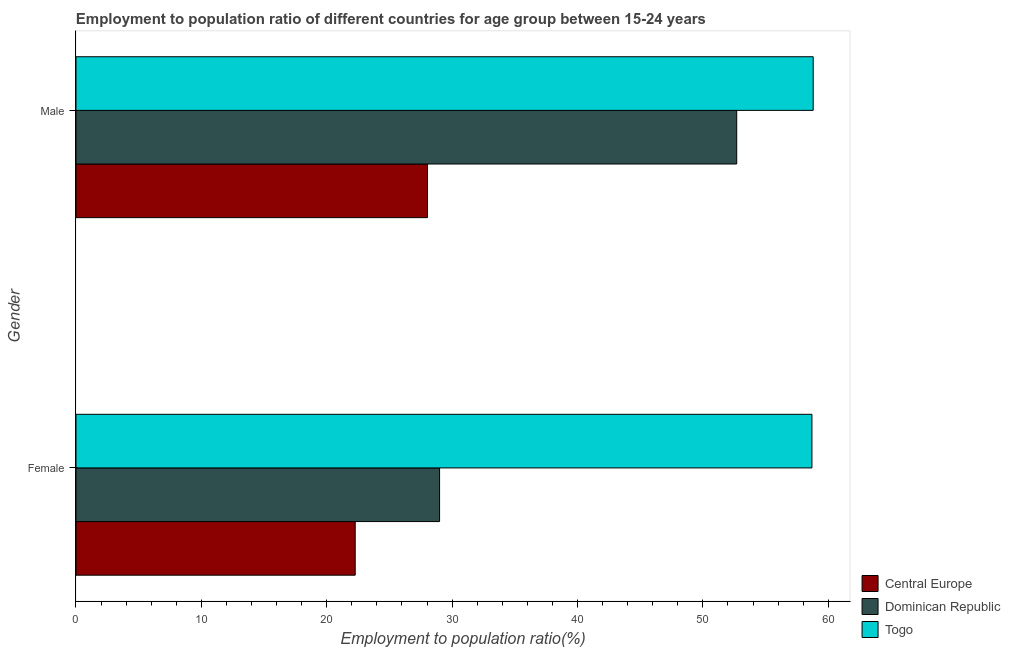How many different coloured bars are there?
Provide a short and direct response. 3. Are the number of bars on each tick of the Y-axis equal?
Your response must be concise. Yes. How many bars are there on the 1st tick from the top?
Your answer should be compact. 3. What is the employment to population ratio(male) in Central Europe?
Provide a succinct answer. 28.04. Across all countries, what is the maximum employment to population ratio(male)?
Offer a very short reply. 58.8. Across all countries, what is the minimum employment to population ratio(female)?
Your answer should be very brief. 22.27. In which country was the employment to population ratio(male) maximum?
Ensure brevity in your answer.  Togo. In which country was the employment to population ratio(male) minimum?
Offer a terse response. Central Europe. What is the total employment to population ratio(male) in the graph?
Offer a terse response. 139.54. What is the difference between the employment to population ratio(female) in Central Europe and that in Dominican Republic?
Give a very brief answer. -6.73. What is the difference between the employment to population ratio(male) in Central Europe and the employment to population ratio(female) in Togo?
Your response must be concise. -30.66. What is the average employment to population ratio(male) per country?
Your answer should be compact. 46.51. What is the difference between the employment to population ratio(female) and employment to population ratio(male) in Dominican Republic?
Offer a terse response. -23.7. In how many countries, is the employment to population ratio(male) greater than 34 %?
Provide a short and direct response. 2. What is the ratio of the employment to population ratio(female) in Togo to that in Dominican Republic?
Ensure brevity in your answer.  2.02. In how many countries, is the employment to population ratio(female) greater than the average employment to population ratio(female) taken over all countries?
Your response must be concise. 1. What does the 1st bar from the top in Male represents?
Give a very brief answer. Togo. What does the 2nd bar from the bottom in Female represents?
Your answer should be very brief. Dominican Republic. Are all the bars in the graph horizontal?
Make the answer very short. Yes. How many countries are there in the graph?
Your response must be concise. 3. Are the values on the major ticks of X-axis written in scientific E-notation?
Make the answer very short. No. Does the graph contain any zero values?
Ensure brevity in your answer.  No. Does the graph contain grids?
Provide a short and direct response. No. Where does the legend appear in the graph?
Provide a short and direct response. Bottom right. What is the title of the graph?
Provide a short and direct response. Employment to population ratio of different countries for age group between 15-24 years. What is the label or title of the X-axis?
Ensure brevity in your answer.  Employment to population ratio(%). What is the label or title of the Y-axis?
Provide a succinct answer. Gender. What is the Employment to population ratio(%) of Central Europe in Female?
Offer a terse response. 22.27. What is the Employment to population ratio(%) of Dominican Republic in Female?
Your answer should be very brief. 29. What is the Employment to population ratio(%) of Togo in Female?
Give a very brief answer. 58.7. What is the Employment to population ratio(%) of Central Europe in Male?
Ensure brevity in your answer.  28.04. What is the Employment to population ratio(%) of Dominican Republic in Male?
Keep it short and to the point. 52.7. What is the Employment to population ratio(%) of Togo in Male?
Your answer should be compact. 58.8. Across all Gender, what is the maximum Employment to population ratio(%) of Central Europe?
Keep it short and to the point. 28.04. Across all Gender, what is the maximum Employment to population ratio(%) in Dominican Republic?
Your answer should be very brief. 52.7. Across all Gender, what is the maximum Employment to population ratio(%) of Togo?
Provide a short and direct response. 58.8. Across all Gender, what is the minimum Employment to population ratio(%) in Central Europe?
Your response must be concise. 22.27. Across all Gender, what is the minimum Employment to population ratio(%) of Dominican Republic?
Give a very brief answer. 29. Across all Gender, what is the minimum Employment to population ratio(%) of Togo?
Make the answer very short. 58.7. What is the total Employment to population ratio(%) of Central Europe in the graph?
Your response must be concise. 50.31. What is the total Employment to population ratio(%) in Dominican Republic in the graph?
Give a very brief answer. 81.7. What is the total Employment to population ratio(%) of Togo in the graph?
Ensure brevity in your answer.  117.5. What is the difference between the Employment to population ratio(%) in Central Europe in Female and that in Male?
Provide a short and direct response. -5.77. What is the difference between the Employment to population ratio(%) of Dominican Republic in Female and that in Male?
Your response must be concise. -23.7. What is the difference between the Employment to population ratio(%) in Central Europe in Female and the Employment to population ratio(%) in Dominican Republic in Male?
Make the answer very short. -30.43. What is the difference between the Employment to population ratio(%) in Central Europe in Female and the Employment to population ratio(%) in Togo in Male?
Offer a very short reply. -36.53. What is the difference between the Employment to population ratio(%) in Dominican Republic in Female and the Employment to population ratio(%) in Togo in Male?
Make the answer very short. -29.8. What is the average Employment to population ratio(%) of Central Europe per Gender?
Ensure brevity in your answer.  25.15. What is the average Employment to population ratio(%) in Dominican Republic per Gender?
Give a very brief answer. 40.85. What is the average Employment to population ratio(%) of Togo per Gender?
Give a very brief answer. 58.75. What is the difference between the Employment to population ratio(%) of Central Europe and Employment to population ratio(%) of Dominican Republic in Female?
Make the answer very short. -6.73. What is the difference between the Employment to population ratio(%) in Central Europe and Employment to population ratio(%) in Togo in Female?
Your answer should be very brief. -36.43. What is the difference between the Employment to population ratio(%) of Dominican Republic and Employment to population ratio(%) of Togo in Female?
Offer a very short reply. -29.7. What is the difference between the Employment to population ratio(%) in Central Europe and Employment to population ratio(%) in Dominican Republic in Male?
Provide a short and direct response. -24.66. What is the difference between the Employment to population ratio(%) of Central Europe and Employment to population ratio(%) of Togo in Male?
Keep it short and to the point. -30.76. What is the difference between the Employment to population ratio(%) in Dominican Republic and Employment to population ratio(%) in Togo in Male?
Ensure brevity in your answer.  -6.1. What is the ratio of the Employment to population ratio(%) in Central Europe in Female to that in Male?
Your response must be concise. 0.79. What is the ratio of the Employment to population ratio(%) of Dominican Republic in Female to that in Male?
Ensure brevity in your answer.  0.55. What is the difference between the highest and the second highest Employment to population ratio(%) in Central Europe?
Ensure brevity in your answer.  5.77. What is the difference between the highest and the second highest Employment to population ratio(%) in Dominican Republic?
Your answer should be compact. 23.7. What is the difference between the highest and the lowest Employment to population ratio(%) in Central Europe?
Ensure brevity in your answer.  5.77. What is the difference between the highest and the lowest Employment to population ratio(%) in Dominican Republic?
Your answer should be compact. 23.7. 